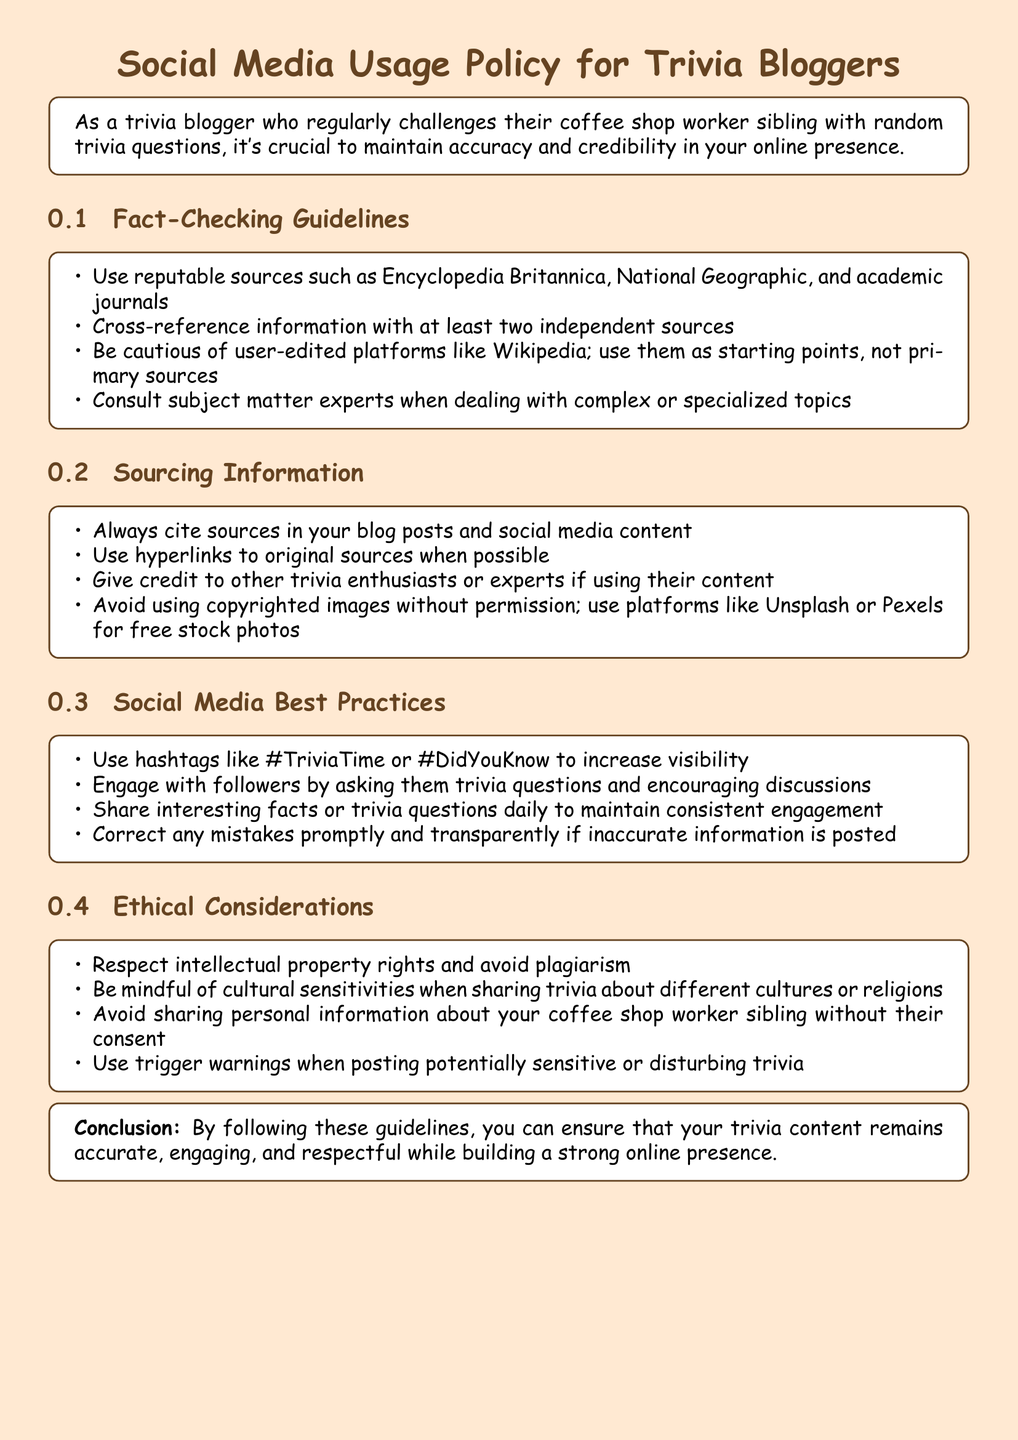What is the title of the document? The title of the document appears in a prominent position and clearly states the focus of the content.
Answer: Social Media Usage Policy for Trivia Bloggers What color is used for the main text? The document specifies the main font color associated with visual elements, which is important for design consistency.
Answer: Coffee Which platform should you avoid using as a primary source? This question focuses on a specific guideline related to source verification and reliability.
Answer: Wikipedia How many independent sources should you cross-reference information with? This is a specific requirement mentioned in the fact-checking guidelines highlighting the importance of accurate information.
Answer: At least two What type of rights should you respect, according to the ethical considerations? This question targets the ethical guidelines about acknowledging the work of others in content creation.
Answer: Intellectual property rights What hashtag is suggested to increase visibility? This question refers to specific social media practices mentioned in the document.
Answer: #TriviaTime What should you do if inaccurate information is posted? This seeks clarity on the recommended action when mistakes occur in published content.
Answer: Correct any mistakes promptly Who should you consult for complex or specialized topics? This question addresses the guideline concerning expert involvement for specific knowledge areas.
Answer: Subject matter experts 